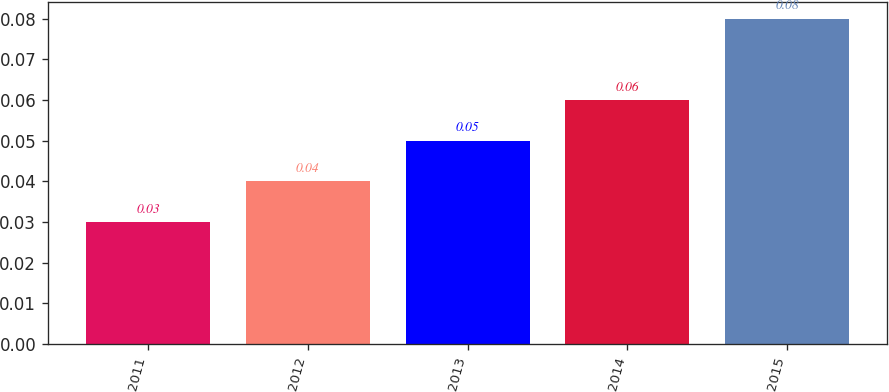<chart> <loc_0><loc_0><loc_500><loc_500><bar_chart><fcel>2011<fcel>2012<fcel>2013<fcel>2014<fcel>2015<nl><fcel>0.03<fcel>0.04<fcel>0.05<fcel>0.06<fcel>0.08<nl></chart> 